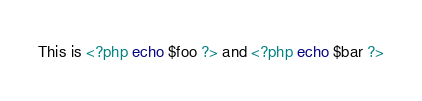Convert code to text. <code><loc_0><loc_0><loc_500><loc_500><_PHP_>This is <?php echo $foo ?> and <?php echo $bar ?></code> 